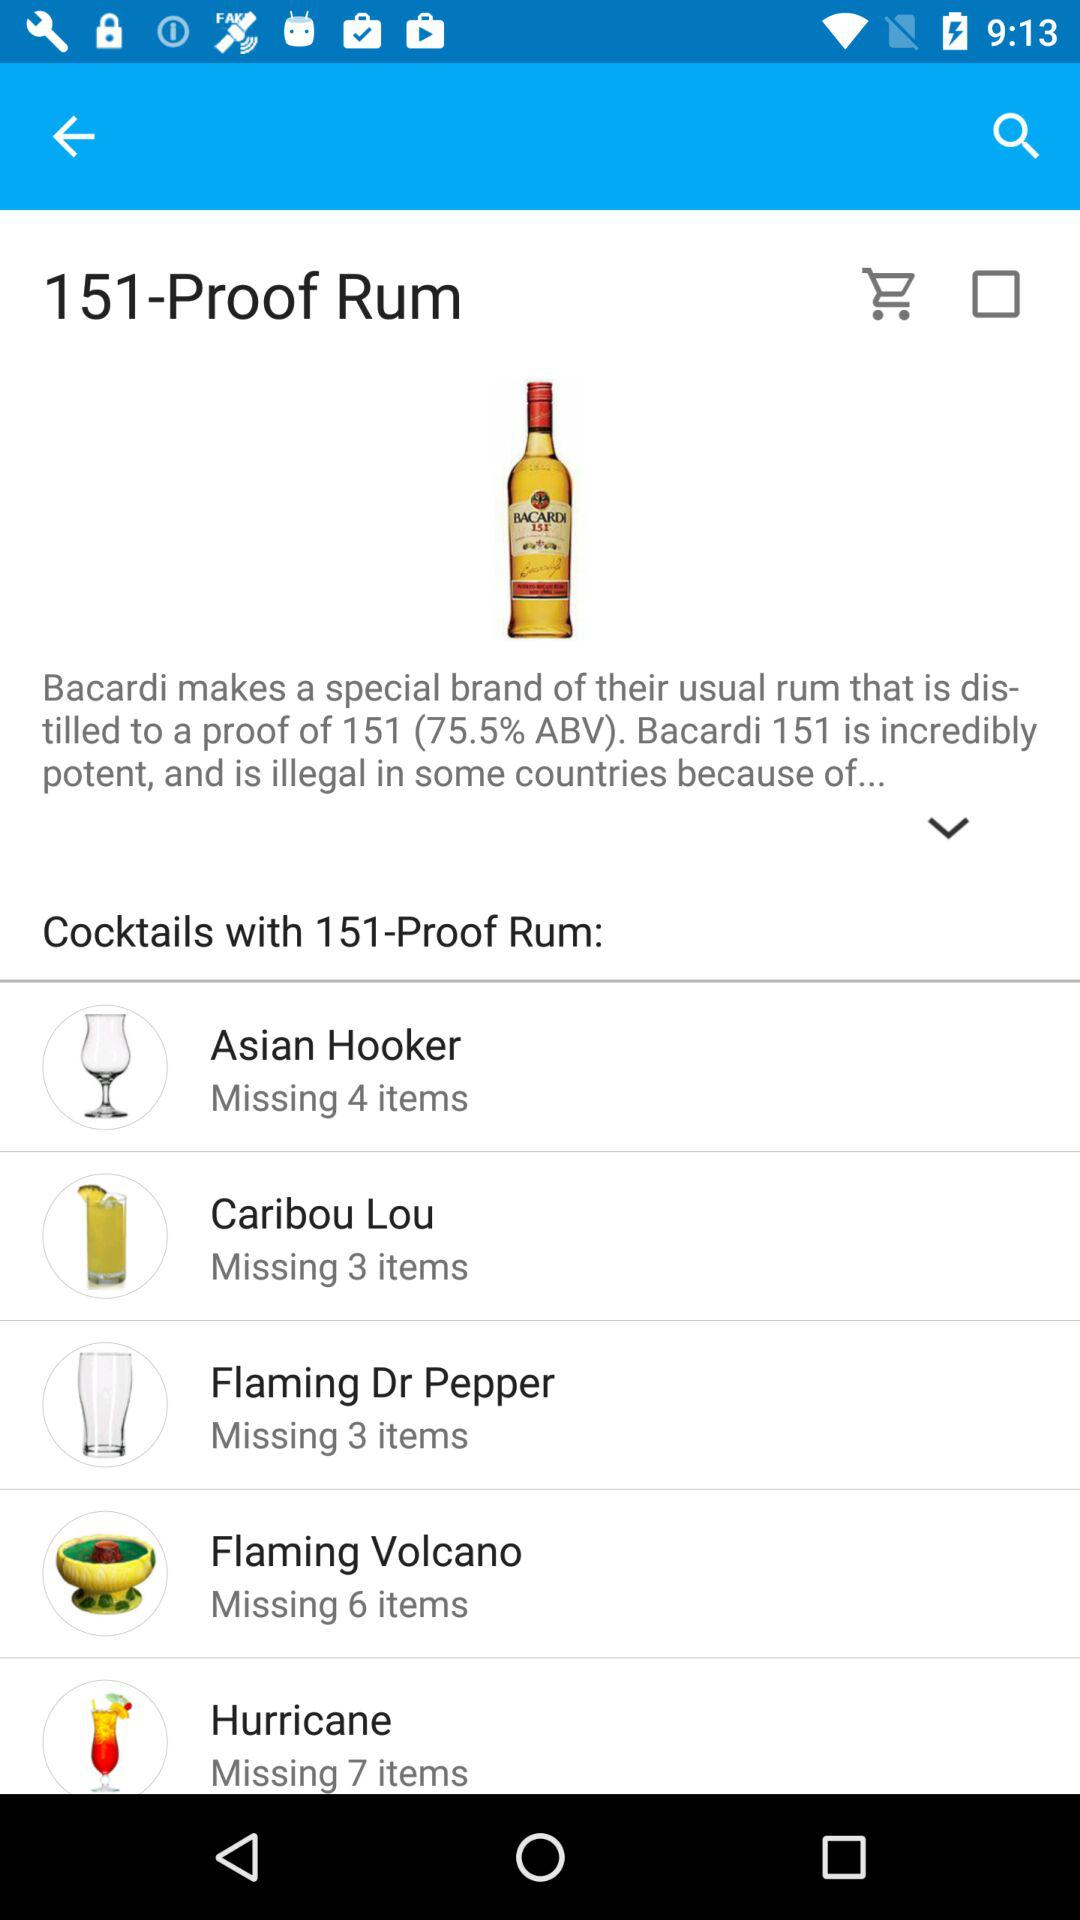What is the count of missing items in "Asian Hooker"? The count of missing items is 4. 